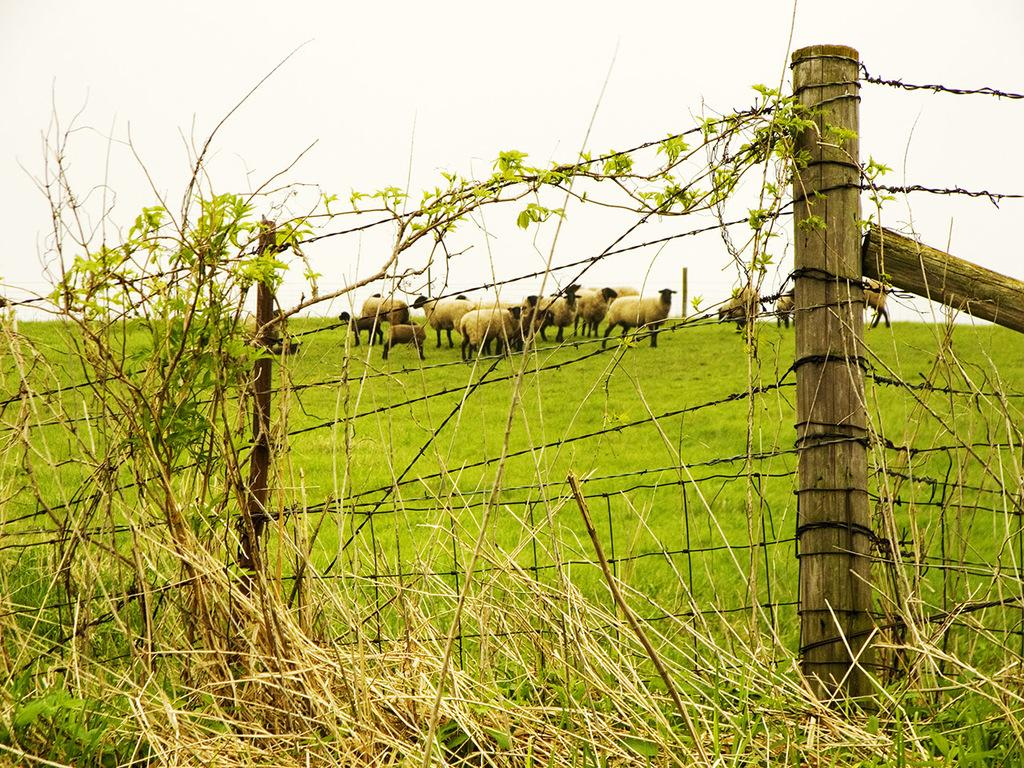What type of barrier can be seen in the image? There is a fence in the image. What is in front of the fence? Dry grass is present in front of the fence. What can be seen in the background of the image? There is a flock of sheep in the background of the image. Where are the sheep standing? The sheep are standing on grassland. What is visible above the grassland? The sky is visible above the grassland. What flavor of addition is being used in the church depicted in the image? There is no church or addition present in the image; it features a fence, dry grass, a flock of sheep, grassland, and the sky. 